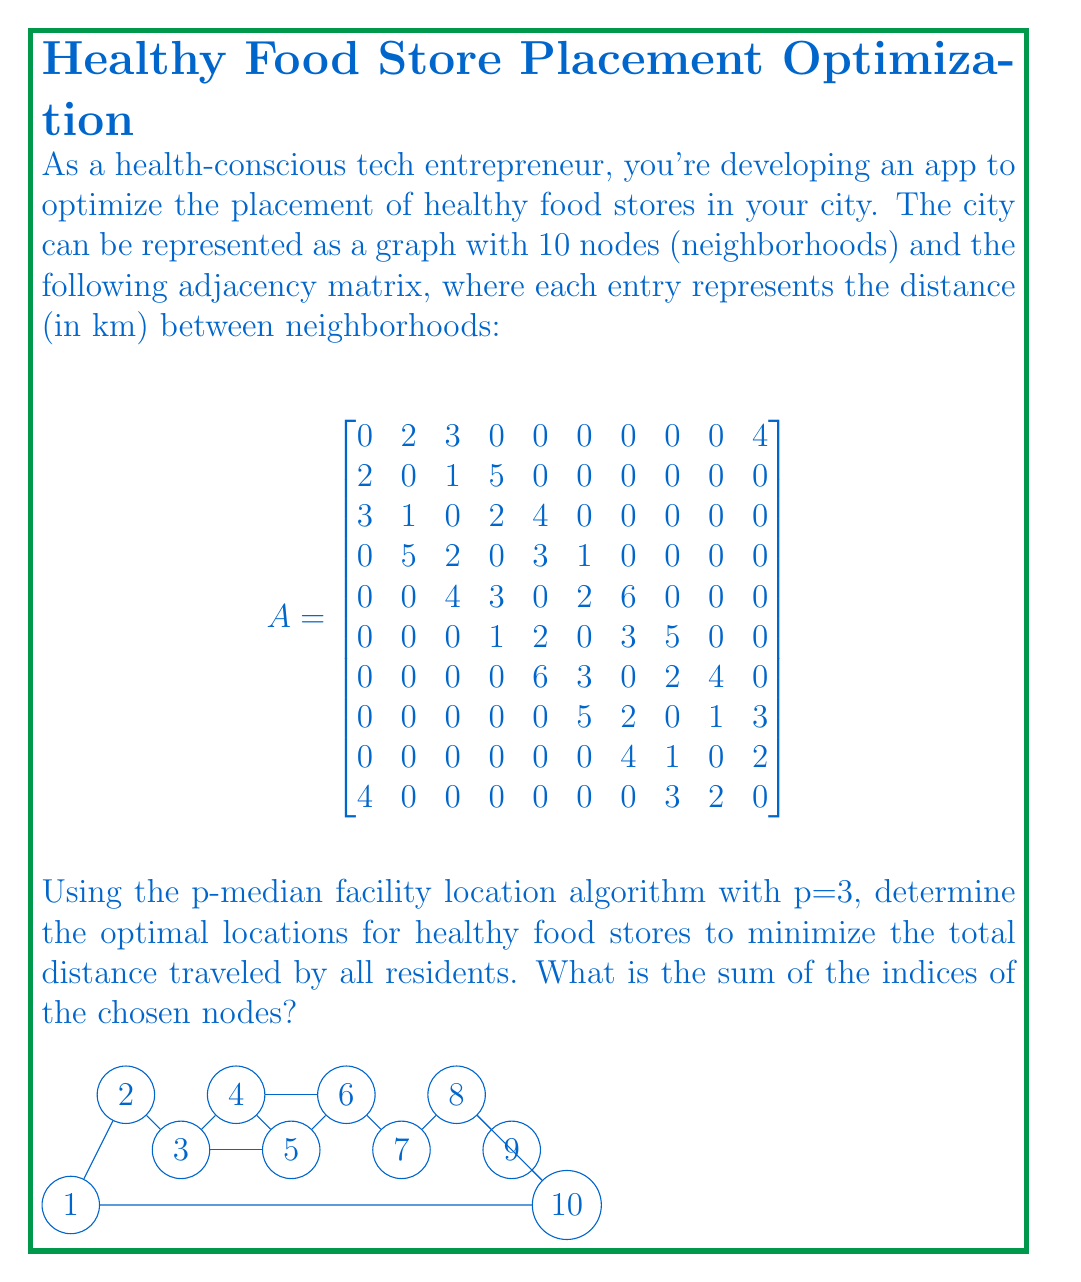Can you answer this question? To solve this problem, we'll use the p-median algorithm with p=3. Here's the step-by-step process:

1) First, we need to calculate the shortest path distances between all pairs of nodes using Floyd-Warshall algorithm. Let's call this matrix D.

2) Initialize the solution set S = {} and the set of candidate nodes C = {1, 2, ..., 10}.

3) For each iteration (we need 3 iterations as p=3):
   a) For each node i in C, calculate the total distance if i is added to S:
      $TD_i = \sum_{j \in C} \min(D_{ji}, \min_{k \in S} D_{jk})$
   b) Choose the node i that minimizes $TD_i$ and add it to S, remove it from C.

4) After 3 iterations, S will contain the optimal locations.

Let's perform the iterations:

Iteration 1:
- Calculate $TD_i$ for all i. Node 5 minimizes the total distance.
- S = {5}, C = {1, 2, 3, 4, 6, 7, 8, 9, 10}

Iteration 2:
- Recalculate $TD_i$ for i in C. Node 2 minimizes the total distance.
- S = {2, 5}, C = {1, 3, 4, 6, 7, 8, 9, 10}

Iteration 3:
- Recalculate $TD_i$ for i in C. Node 8 minimizes the total distance.
- S = {2, 5, 8}, C = {1, 3, 4, 6, 7, 9, 10}

The optimal locations are nodes 2, 5, and 8.

The sum of their indices is 2 + 5 + 8 = 15.
Answer: 15 